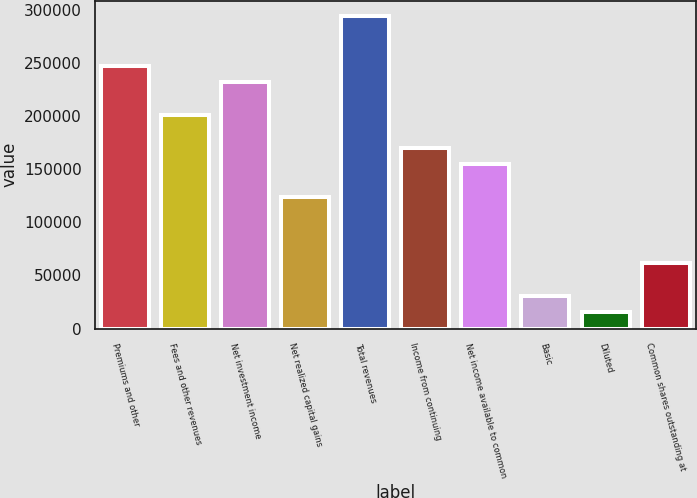Convert chart. <chart><loc_0><loc_0><loc_500><loc_500><bar_chart><fcel>Premiums and other<fcel>Fees and other revenues<fcel>Net investment income<fcel>Net realized capital gains<fcel>Total revenues<fcel>Income from continuing<fcel>Net income available to common<fcel>Basic<fcel>Diluted<fcel>Common shares outstanding at<nl><fcel>247232<fcel>200876<fcel>231780<fcel>123616<fcel>293588<fcel>169972<fcel>154520<fcel>30904.8<fcel>15452.8<fcel>61808.6<nl></chart> 